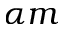Convert formula to latex. <formula><loc_0><loc_0><loc_500><loc_500>\alpha m</formula> 